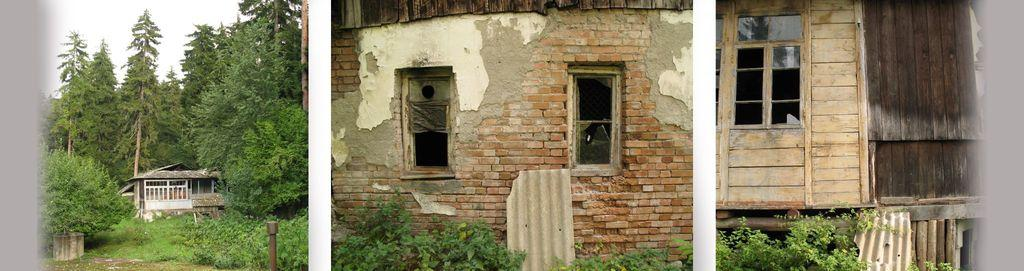What is the main subject of the image? The main subject of the image is a collage of images. What types of structures are included in the collage? The collage includes images of houses. What natural elements are included in the collage? The collage includes images of trees and plants. What type of drum can be seen in the collage? There is no drum present in the collage; it only includes images of houses, trees, and plants. 